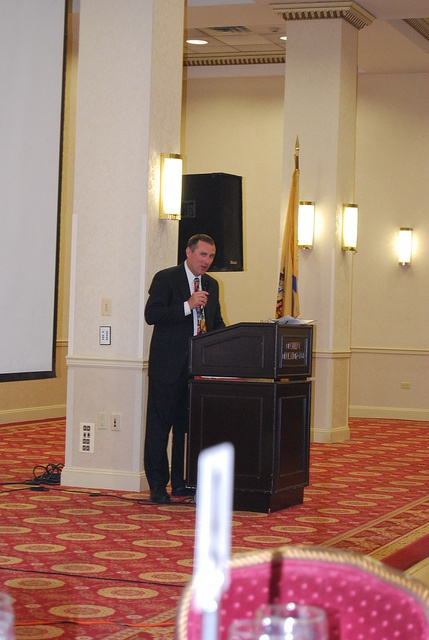Describe the objects in this image and their specific colors. I can see chair in darkgray, brown, and violet tones, people in darkgray, black, brown, maroon, and gray tones, wine glass in darkgray, violet, brown, and lavender tones, wine glass in darkgray, violet, and lightpink tones, and tie in darkgray, gray, black, brown, and maroon tones in this image. 